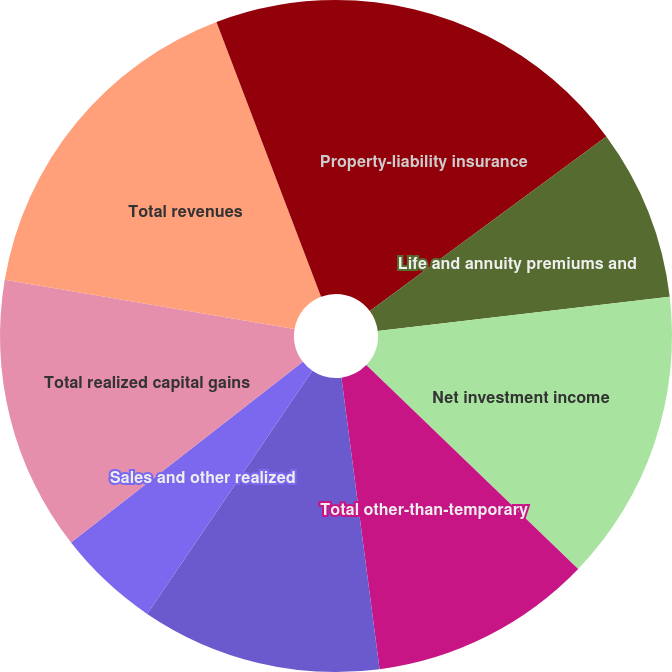Convert chart to OTSL. <chart><loc_0><loc_0><loc_500><loc_500><pie_chart><fcel>Property-liability insurance<fcel>Life and annuity premiums and<fcel>Net investment income<fcel>Total other-than-temporary<fcel>Net other-than-temporary<fcel>Sales and other realized<fcel>Total realized capital gains<fcel>Total revenues<fcel>Life and annuity contract<nl><fcel>14.88%<fcel>8.26%<fcel>14.05%<fcel>10.74%<fcel>11.57%<fcel>4.96%<fcel>13.22%<fcel>16.53%<fcel>5.79%<nl></chart> 